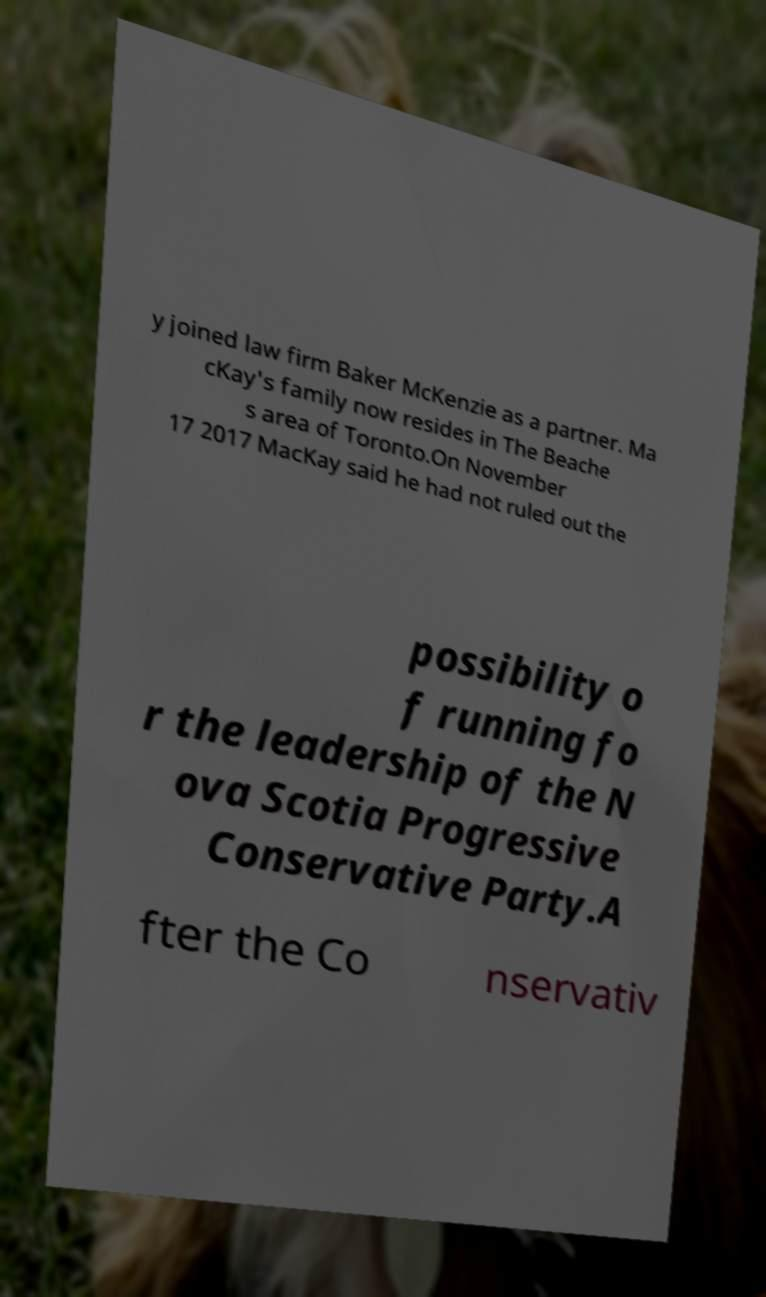Can you accurately transcribe the text from the provided image for me? y joined law firm Baker McKenzie as a partner. Ma cKay's family now resides in The Beache s area of Toronto.On November 17 2017 MacKay said he had not ruled out the possibility o f running fo r the leadership of the N ova Scotia Progressive Conservative Party.A fter the Co nservativ 